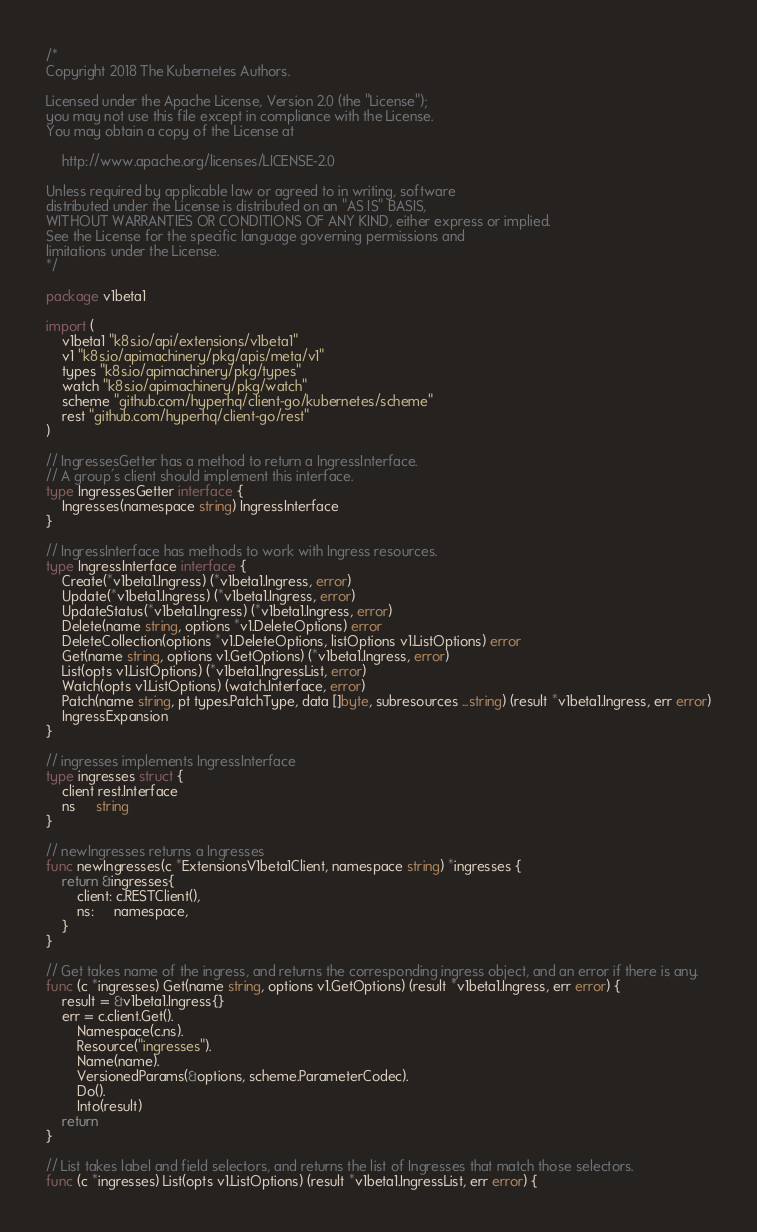<code> <loc_0><loc_0><loc_500><loc_500><_Go_>/*
Copyright 2018 The Kubernetes Authors.

Licensed under the Apache License, Version 2.0 (the "License");
you may not use this file except in compliance with the License.
You may obtain a copy of the License at

    http://www.apache.org/licenses/LICENSE-2.0

Unless required by applicable law or agreed to in writing, software
distributed under the License is distributed on an "AS IS" BASIS,
WITHOUT WARRANTIES OR CONDITIONS OF ANY KIND, either express or implied.
See the License for the specific language governing permissions and
limitations under the License.
*/

package v1beta1

import (
	v1beta1 "k8s.io/api/extensions/v1beta1"
	v1 "k8s.io/apimachinery/pkg/apis/meta/v1"
	types "k8s.io/apimachinery/pkg/types"
	watch "k8s.io/apimachinery/pkg/watch"
	scheme "github.com/hyperhq/client-go/kubernetes/scheme"
	rest "github.com/hyperhq/client-go/rest"
)

// IngressesGetter has a method to return a IngressInterface.
// A group's client should implement this interface.
type IngressesGetter interface {
	Ingresses(namespace string) IngressInterface
}

// IngressInterface has methods to work with Ingress resources.
type IngressInterface interface {
	Create(*v1beta1.Ingress) (*v1beta1.Ingress, error)
	Update(*v1beta1.Ingress) (*v1beta1.Ingress, error)
	UpdateStatus(*v1beta1.Ingress) (*v1beta1.Ingress, error)
	Delete(name string, options *v1.DeleteOptions) error
	DeleteCollection(options *v1.DeleteOptions, listOptions v1.ListOptions) error
	Get(name string, options v1.GetOptions) (*v1beta1.Ingress, error)
	List(opts v1.ListOptions) (*v1beta1.IngressList, error)
	Watch(opts v1.ListOptions) (watch.Interface, error)
	Patch(name string, pt types.PatchType, data []byte, subresources ...string) (result *v1beta1.Ingress, err error)
	IngressExpansion
}

// ingresses implements IngressInterface
type ingresses struct {
	client rest.Interface
	ns     string
}

// newIngresses returns a Ingresses
func newIngresses(c *ExtensionsV1beta1Client, namespace string) *ingresses {
	return &ingresses{
		client: c.RESTClient(),
		ns:     namespace,
	}
}

// Get takes name of the ingress, and returns the corresponding ingress object, and an error if there is any.
func (c *ingresses) Get(name string, options v1.GetOptions) (result *v1beta1.Ingress, err error) {
	result = &v1beta1.Ingress{}
	err = c.client.Get().
		Namespace(c.ns).
		Resource("ingresses").
		Name(name).
		VersionedParams(&options, scheme.ParameterCodec).
		Do().
		Into(result)
	return
}

// List takes label and field selectors, and returns the list of Ingresses that match those selectors.
func (c *ingresses) List(opts v1.ListOptions) (result *v1beta1.IngressList, err error) {</code> 